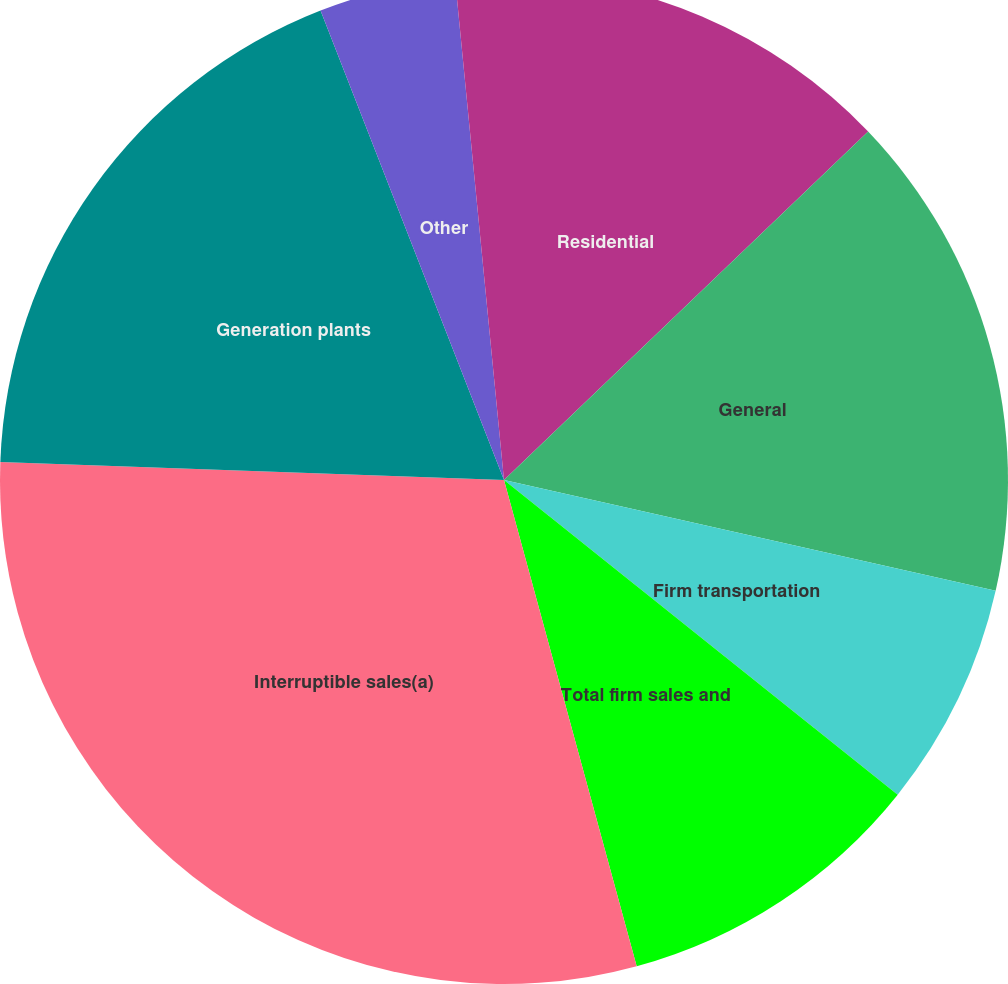Convert chart. <chart><loc_0><loc_0><loc_500><loc_500><pie_chart><fcel>Residential<fcel>General<fcel>Firm transportation<fcel>Total firm sales and<fcel>Interruptible sales(a)<fcel>Generation plants<fcel>Other<fcel>Total<nl><fcel>12.85%<fcel>15.68%<fcel>7.2%<fcel>10.03%<fcel>29.81%<fcel>18.5%<fcel>4.38%<fcel>1.55%<nl></chart> 